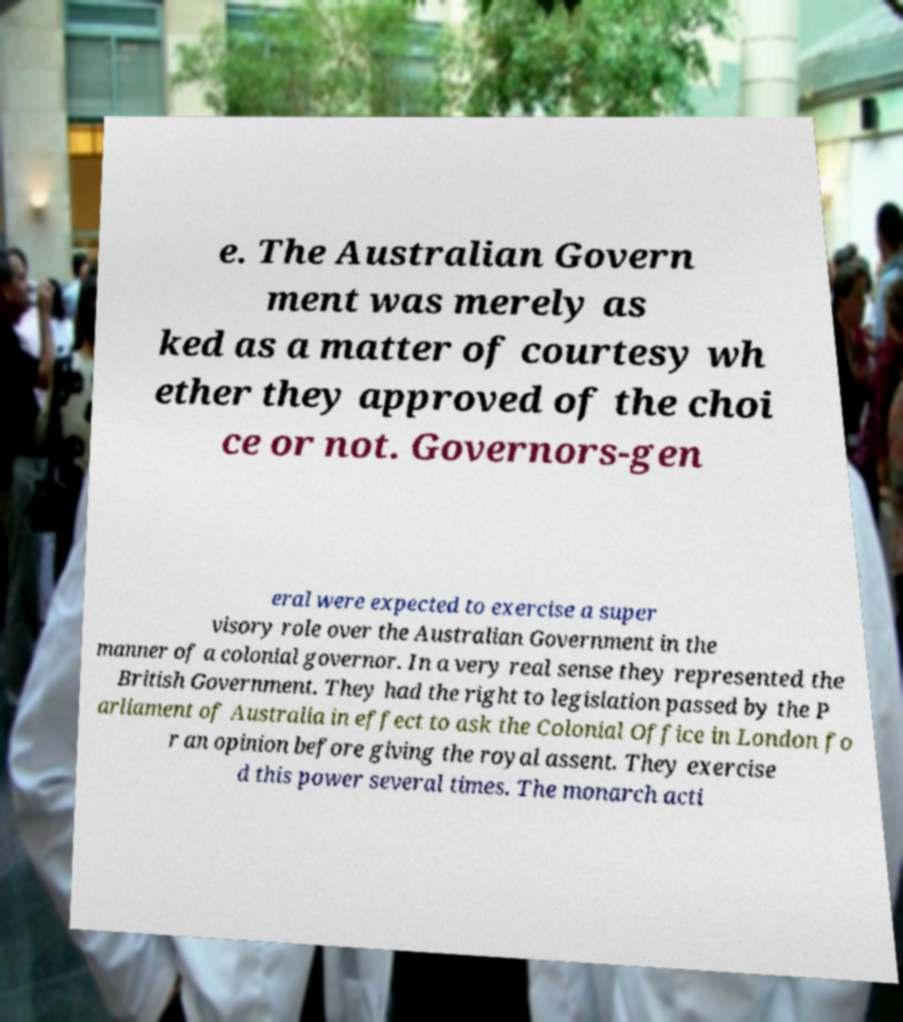Please identify and transcribe the text found in this image. e. The Australian Govern ment was merely as ked as a matter of courtesy wh ether they approved of the choi ce or not. Governors-gen eral were expected to exercise a super visory role over the Australian Government in the manner of a colonial governor. In a very real sense they represented the British Government. They had the right to legislation passed by the P arliament of Australia in effect to ask the Colonial Office in London fo r an opinion before giving the royal assent. They exercise d this power several times. The monarch acti 